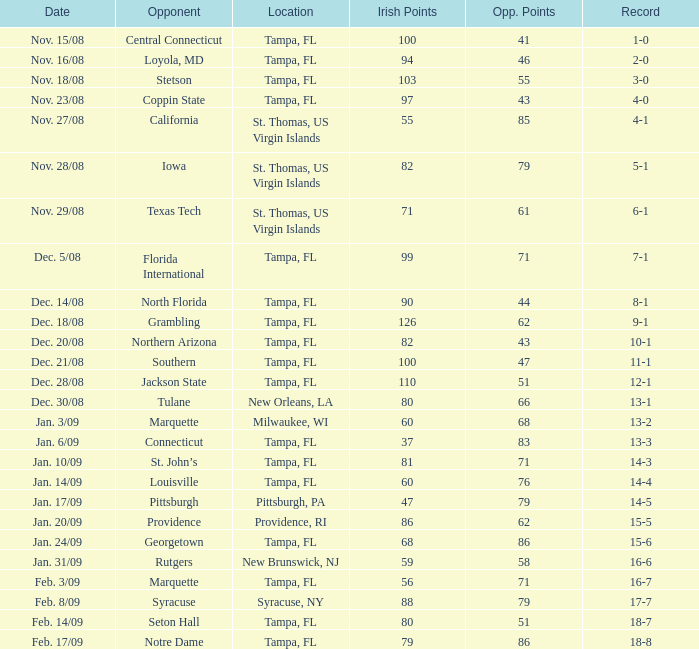What is the count of adversaries located in syracuse, ny? 1.0. 